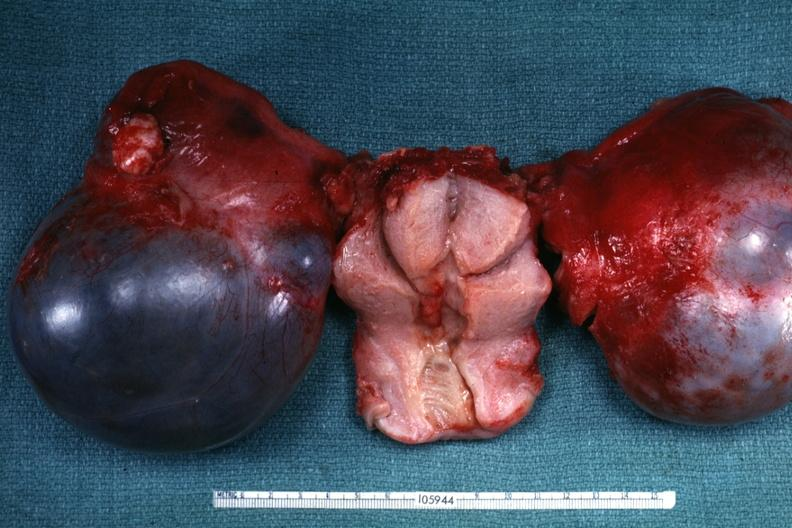s cystadenocarcinoma malignancy not obvious from gross appearance?
Answer the question using a single word or phrase. Yes 